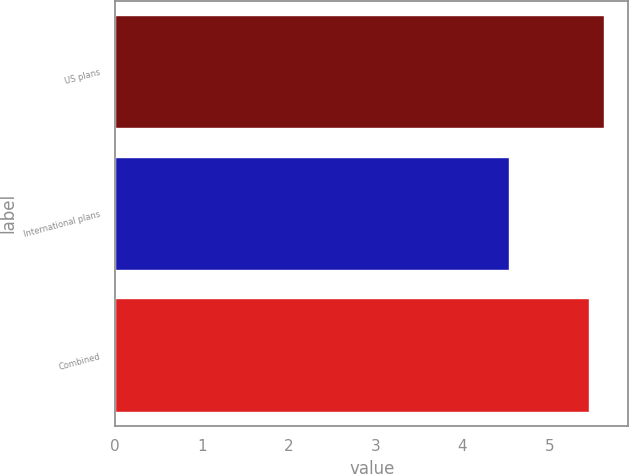<chart> <loc_0><loc_0><loc_500><loc_500><bar_chart><fcel>US plans<fcel>International plans<fcel>Combined<nl><fcel>5.63<fcel>4.54<fcel>5.46<nl></chart> 